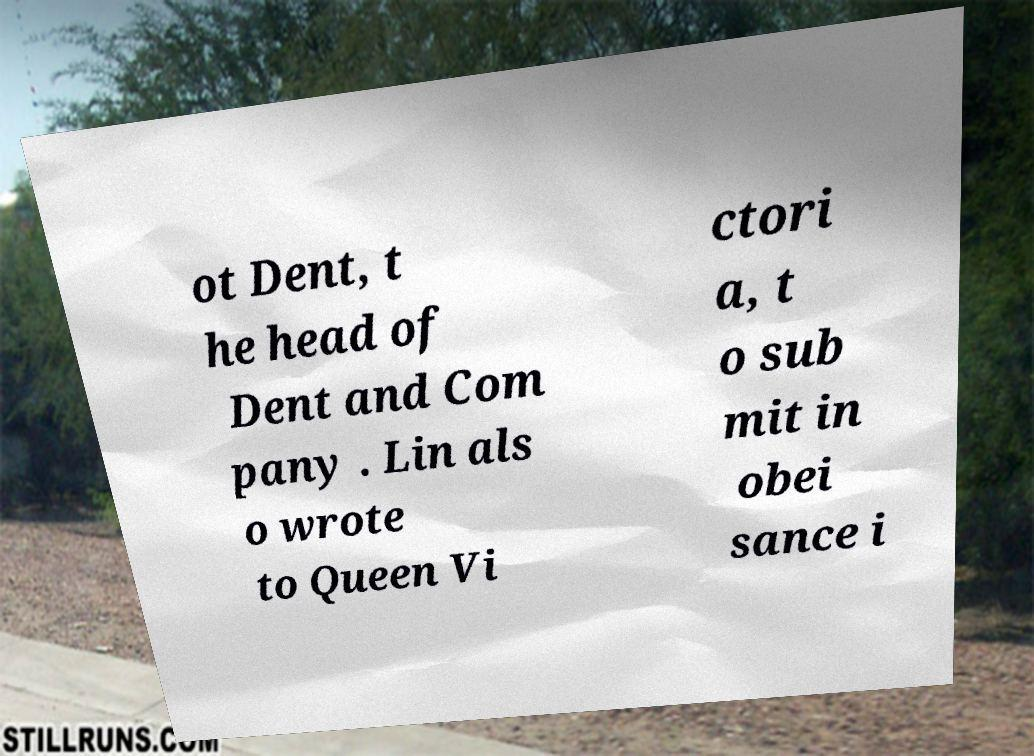What messages or text are displayed in this image? I need them in a readable, typed format. ot Dent, t he head of Dent and Com pany . Lin als o wrote to Queen Vi ctori a, t o sub mit in obei sance i 